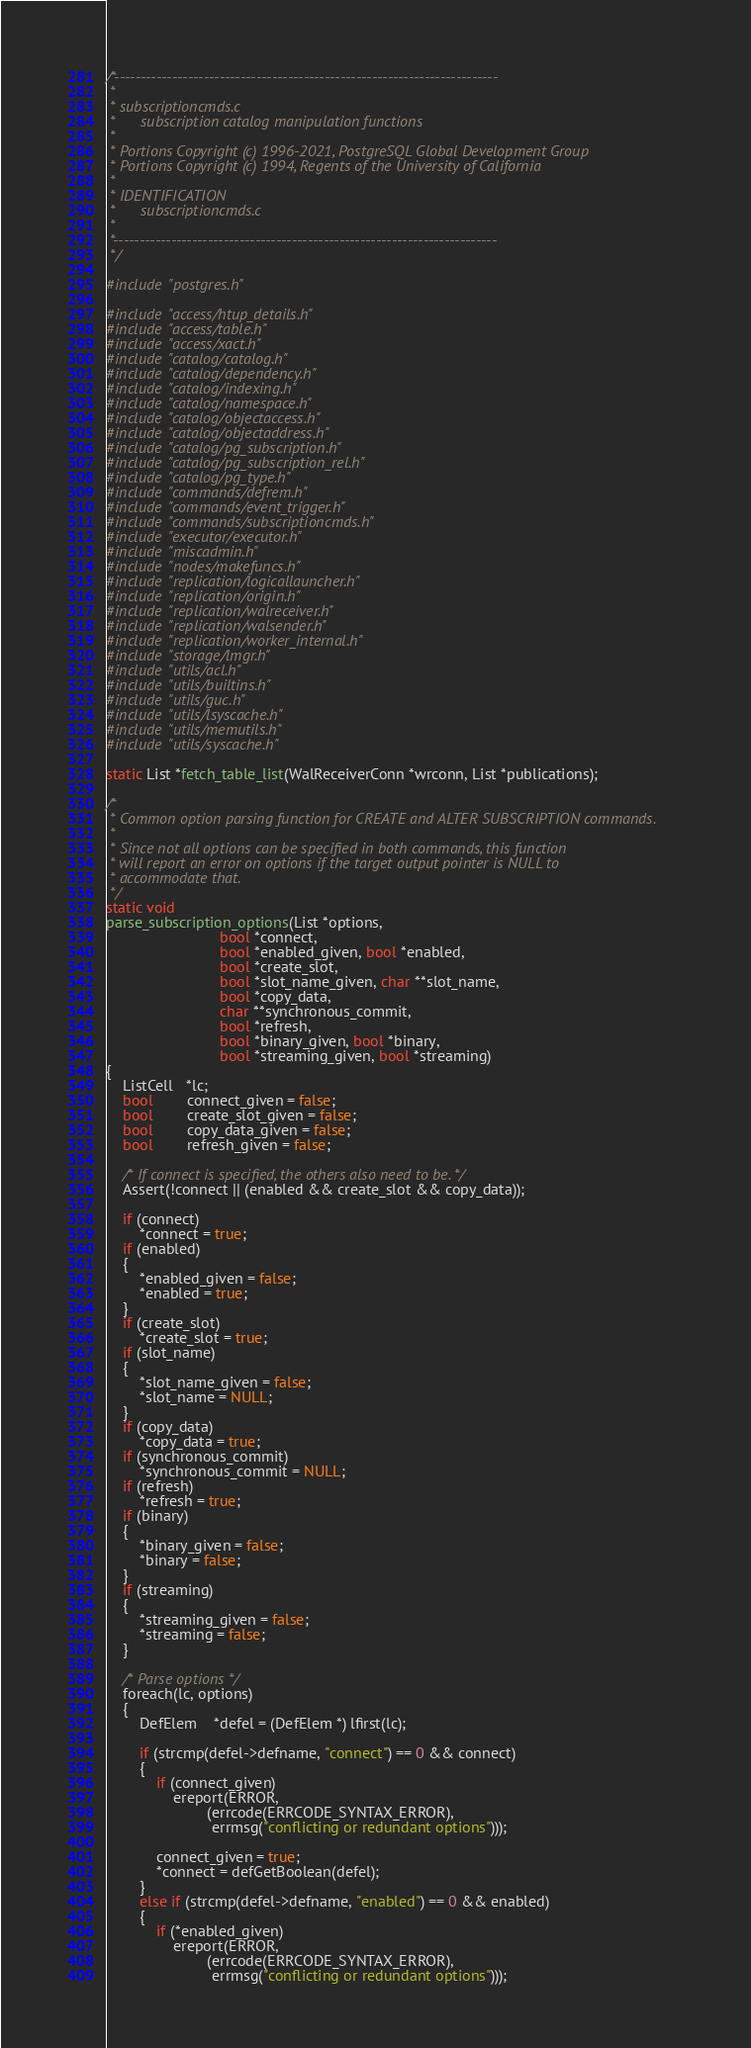Convert code to text. <code><loc_0><loc_0><loc_500><loc_500><_C_>/*-------------------------------------------------------------------------
 *
 * subscriptioncmds.c
 *		subscription catalog manipulation functions
 *
 * Portions Copyright (c) 1996-2021, PostgreSQL Global Development Group
 * Portions Copyright (c) 1994, Regents of the University of California
 *
 * IDENTIFICATION
 *		subscriptioncmds.c
 *
 *-------------------------------------------------------------------------
 */

#include "postgres.h"

#include "access/htup_details.h"
#include "access/table.h"
#include "access/xact.h"
#include "catalog/catalog.h"
#include "catalog/dependency.h"
#include "catalog/indexing.h"
#include "catalog/namespace.h"
#include "catalog/objectaccess.h"
#include "catalog/objectaddress.h"
#include "catalog/pg_subscription.h"
#include "catalog/pg_subscription_rel.h"
#include "catalog/pg_type.h"
#include "commands/defrem.h"
#include "commands/event_trigger.h"
#include "commands/subscriptioncmds.h"
#include "executor/executor.h"
#include "miscadmin.h"
#include "nodes/makefuncs.h"
#include "replication/logicallauncher.h"
#include "replication/origin.h"
#include "replication/walreceiver.h"
#include "replication/walsender.h"
#include "replication/worker_internal.h"
#include "storage/lmgr.h"
#include "utils/acl.h"
#include "utils/builtins.h"
#include "utils/guc.h"
#include "utils/lsyscache.h"
#include "utils/memutils.h"
#include "utils/syscache.h"

static List *fetch_table_list(WalReceiverConn *wrconn, List *publications);

/*
 * Common option parsing function for CREATE and ALTER SUBSCRIPTION commands.
 *
 * Since not all options can be specified in both commands, this function
 * will report an error on options if the target output pointer is NULL to
 * accommodate that.
 */
static void
parse_subscription_options(List *options,
						   bool *connect,
						   bool *enabled_given, bool *enabled,
						   bool *create_slot,
						   bool *slot_name_given, char **slot_name,
						   bool *copy_data,
						   char **synchronous_commit,
						   bool *refresh,
						   bool *binary_given, bool *binary,
						   bool *streaming_given, bool *streaming)
{
	ListCell   *lc;
	bool		connect_given = false;
	bool		create_slot_given = false;
	bool		copy_data_given = false;
	bool		refresh_given = false;

	/* If connect is specified, the others also need to be. */
	Assert(!connect || (enabled && create_slot && copy_data));

	if (connect)
		*connect = true;
	if (enabled)
	{
		*enabled_given = false;
		*enabled = true;
	}
	if (create_slot)
		*create_slot = true;
	if (slot_name)
	{
		*slot_name_given = false;
		*slot_name = NULL;
	}
	if (copy_data)
		*copy_data = true;
	if (synchronous_commit)
		*synchronous_commit = NULL;
	if (refresh)
		*refresh = true;
	if (binary)
	{
		*binary_given = false;
		*binary = false;
	}
	if (streaming)
	{
		*streaming_given = false;
		*streaming = false;
	}

	/* Parse options */
	foreach(lc, options)
	{
		DefElem    *defel = (DefElem *) lfirst(lc);

		if (strcmp(defel->defname, "connect") == 0 && connect)
		{
			if (connect_given)
				ereport(ERROR,
						(errcode(ERRCODE_SYNTAX_ERROR),
						 errmsg("conflicting or redundant options")));

			connect_given = true;
			*connect = defGetBoolean(defel);
		}
		else if (strcmp(defel->defname, "enabled") == 0 && enabled)
		{
			if (*enabled_given)
				ereport(ERROR,
						(errcode(ERRCODE_SYNTAX_ERROR),
						 errmsg("conflicting or redundant options")));
</code> 